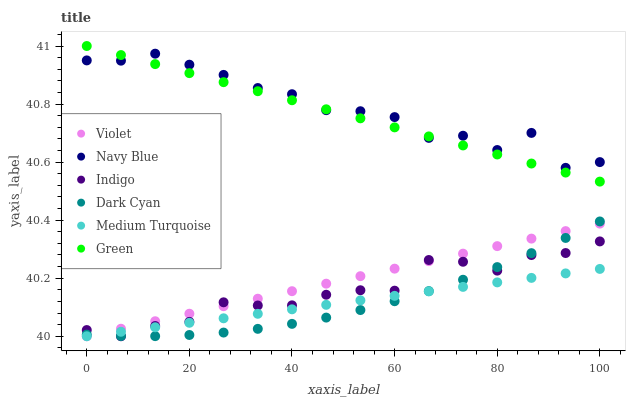Does Medium Turquoise have the minimum area under the curve?
Answer yes or no. Yes. Does Navy Blue have the maximum area under the curve?
Answer yes or no. Yes. Does Green have the minimum area under the curve?
Answer yes or no. No. Does Green have the maximum area under the curve?
Answer yes or no. No. Is Green the smoothest?
Answer yes or no. Yes. Is Navy Blue the roughest?
Answer yes or no. Yes. Is Navy Blue the smoothest?
Answer yes or no. No. Is Green the roughest?
Answer yes or no. No. Does Indigo have the lowest value?
Answer yes or no. Yes. Does Green have the lowest value?
Answer yes or no. No. Does Green have the highest value?
Answer yes or no. Yes. Does Navy Blue have the highest value?
Answer yes or no. No. Is Medium Turquoise less than Navy Blue?
Answer yes or no. Yes. Is Green greater than Indigo?
Answer yes or no. Yes. Does Medium Turquoise intersect Dark Cyan?
Answer yes or no. Yes. Is Medium Turquoise less than Dark Cyan?
Answer yes or no. No. Is Medium Turquoise greater than Dark Cyan?
Answer yes or no. No. Does Medium Turquoise intersect Navy Blue?
Answer yes or no. No. 